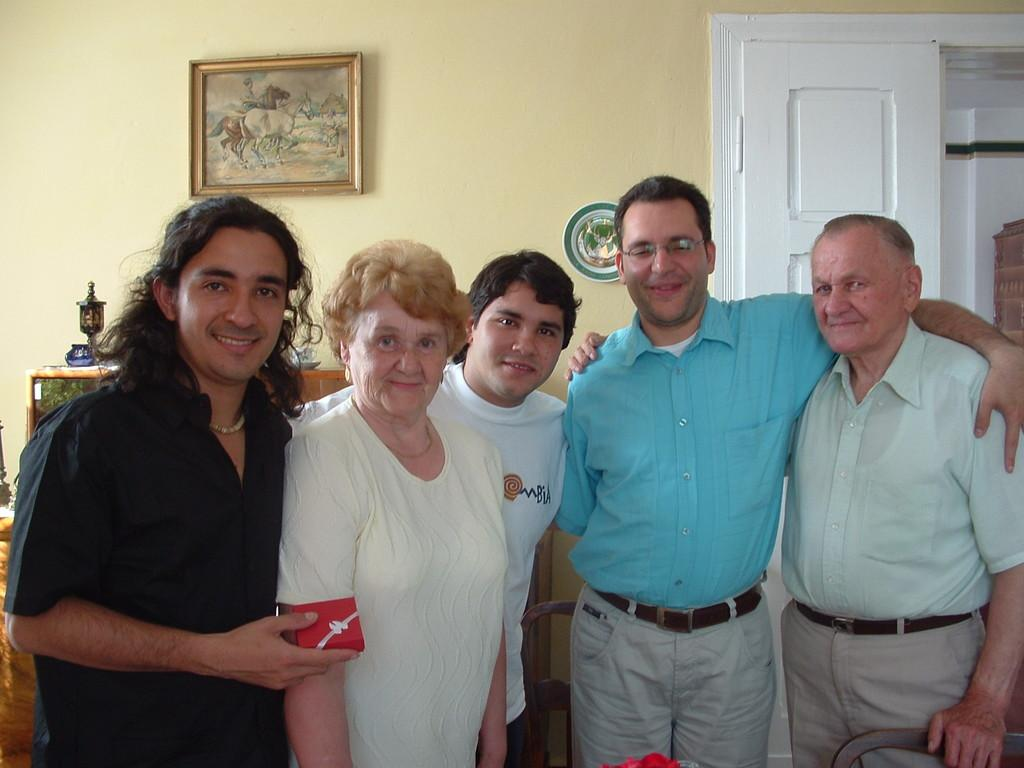What are the people in the image doing? The people in the image are standing and smiling. What can be seen beneath the people's feet in the image? There is a floor visible in the image. What architectural features can be seen in the background of the image? There are doors in the background of the image. What type of decorations are present on the wall in the background? Wall hangings are present on the wall in the background. What type of decorations can be seen on a cupboard in the background? Decorations are visible on a cupboard in the background. What type of underwear is visible on the people in the image? There is no underwear visible on the people in the image. What is the people's desire in the image? There is no indication of the people's desires in the image. 